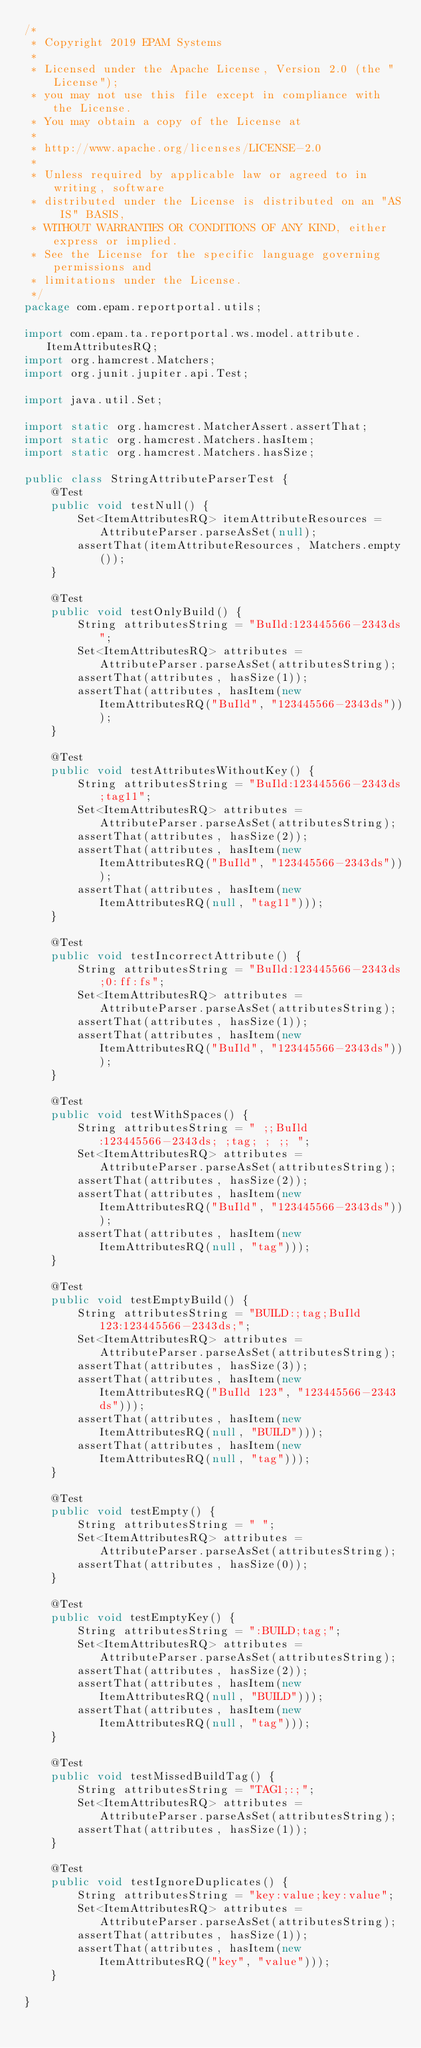Convert code to text. <code><loc_0><loc_0><loc_500><loc_500><_Java_>/*
 * Copyright 2019 EPAM Systems
 *
 * Licensed under the Apache License, Version 2.0 (the "License");
 * you may not use this file except in compliance with the License.
 * You may obtain a copy of the License at
 *
 * http://www.apache.org/licenses/LICENSE-2.0
 *
 * Unless required by applicable law or agreed to in writing, software
 * distributed under the License is distributed on an "AS IS" BASIS,
 * WITHOUT WARRANTIES OR CONDITIONS OF ANY KIND, either express or implied.
 * See the License for the specific language governing permissions and
 * limitations under the License.
 */
package com.epam.reportportal.utils;

import com.epam.ta.reportportal.ws.model.attribute.ItemAttributesRQ;
import org.hamcrest.Matchers;
import org.junit.jupiter.api.Test;

import java.util.Set;

import static org.hamcrest.MatcherAssert.assertThat;
import static org.hamcrest.Matchers.hasItem;
import static org.hamcrest.Matchers.hasSize;

public class StringAttributeParserTest {
	@Test
	public void testNull() {
		Set<ItemAttributesRQ> itemAttributeResources = AttributeParser.parseAsSet(null);
		assertThat(itemAttributeResources, Matchers.empty());
	}

	@Test
	public void testOnlyBuild() {
		String attributesString = "BuIld:123445566-2343ds";
		Set<ItemAttributesRQ> attributes = AttributeParser.parseAsSet(attributesString);
		assertThat(attributes, hasSize(1));
		assertThat(attributes, hasItem(new ItemAttributesRQ("BuIld", "123445566-2343ds")));
	}

	@Test
	public void testAttributesWithoutKey() {
		String attributesString = "BuIld:123445566-2343ds;tag11";
		Set<ItemAttributesRQ> attributes = AttributeParser.parseAsSet(attributesString);
		assertThat(attributes, hasSize(2));
		assertThat(attributes, hasItem(new ItemAttributesRQ("BuIld", "123445566-2343ds")));
		assertThat(attributes, hasItem(new ItemAttributesRQ(null, "tag11")));
	}

	@Test
	public void testIncorrectAttribute() {
		String attributesString = "BuIld:123445566-2343ds;0:ff:fs";
		Set<ItemAttributesRQ> attributes = AttributeParser.parseAsSet(attributesString);
		assertThat(attributes, hasSize(1));
		assertThat(attributes, hasItem(new ItemAttributesRQ("BuIld", "123445566-2343ds")));
	}

	@Test
	public void testWithSpaces() {
		String attributesString = " ;;BuIld:123445566-2343ds; ;tag; ; ;; ";
		Set<ItemAttributesRQ> attributes = AttributeParser.parseAsSet(attributesString);
		assertThat(attributes, hasSize(2));
		assertThat(attributes, hasItem(new ItemAttributesRQ("BuIld", "123445566-2343ds")));
		assertThat(attributes, hasItem(new ItemAttributesRQ(null, "tag")));
	}

	@Test
	public void testEmptyBuild() {
		String attributesString = "BUILD:;tag;BuIld 123:123445566-2343ds;";
		Set<ItemAttributesRQ> attributes = AttributeParser.parseAsSet(attributesString);
		assertThat(attributes, hasSize(3));
		assertThat(attributes, hasItem(new ItemAttributesRQ("BuIld 123", "123445566-2343ds")));
		assertThat(attributes, hasItem(new ItemAttributesRQ(null, "BUILD")));
		assertThat(attributes, hasItem(new ItemAttributesRQ(null, "tag")));
	}

	@Test
	public void testEmpty() {
		String attributesString = " ";
		Set<ItemAttributesRQ> attributes = AttributeParser.parseAsSet(attributesString);
		assertThat(attributes, hasSize(0));
	}

	@Test
	public void testEmptyKey() {
		String attributesString = ":BUILD;tag;";
		Set<ItemAttributesRQ> attributes = AttributeParser.parseAsSet(attributesString);
		assertThat(attributes, hasSize(2));
		assertThat(attributes, hasItem(new ItemAttributesRQ(null, "BUILD")));
		assertThat(attributes, hasItem(new ItemAttributesRQ(null, "tag")));
	}

	@Test
	public void testMissedBuildTag() {
		String attributesString = "TAG1;:;";
		Set<ItemAttributesRQ> attributes = AttributeParser.parseAsSet(attributesString);
		assertThat(attributes, hasSize(1));
	}

	@Test
	public void testIgnoreDuplicates() {
		String attributesString = "key:value;key:value";
		Set<ItemAttributesRQ> attributes = AttributeParser.parseAsSet(attributesString);
		assertThat(attributes, hasSize(1));
		assertThat(attributes, hasItem(new ItemAttributesRQ("key", "value")));
	}

}
</code> 